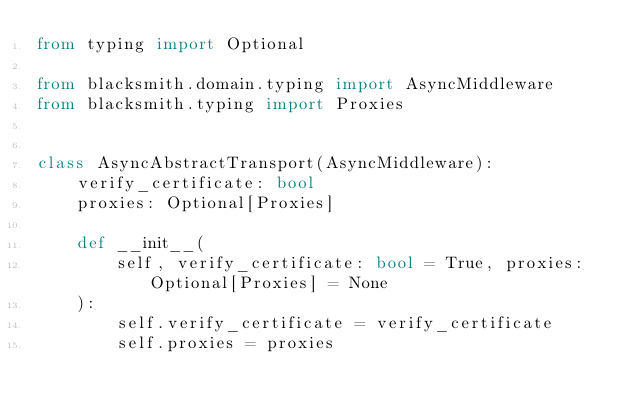Convert code to text. <code><loc_0><loc_0><loc_500><loc_500><_Python_>from typing import Optional

from blacksmith.domain.typing import AsyncMiddleware
from blacksmith.typing import Proxies


class AsyncAbstractTransport(AsyncMiddleware):
    verify_certificate: bool
    proxies: Optional[Proxies]

    def __init__(
        self, verify_certificate: bool = True, proxies: Optional[Proxies] = None
    ):
        self.verify_certificate = verify_certificate
        self.proxies = proxies
</code> 